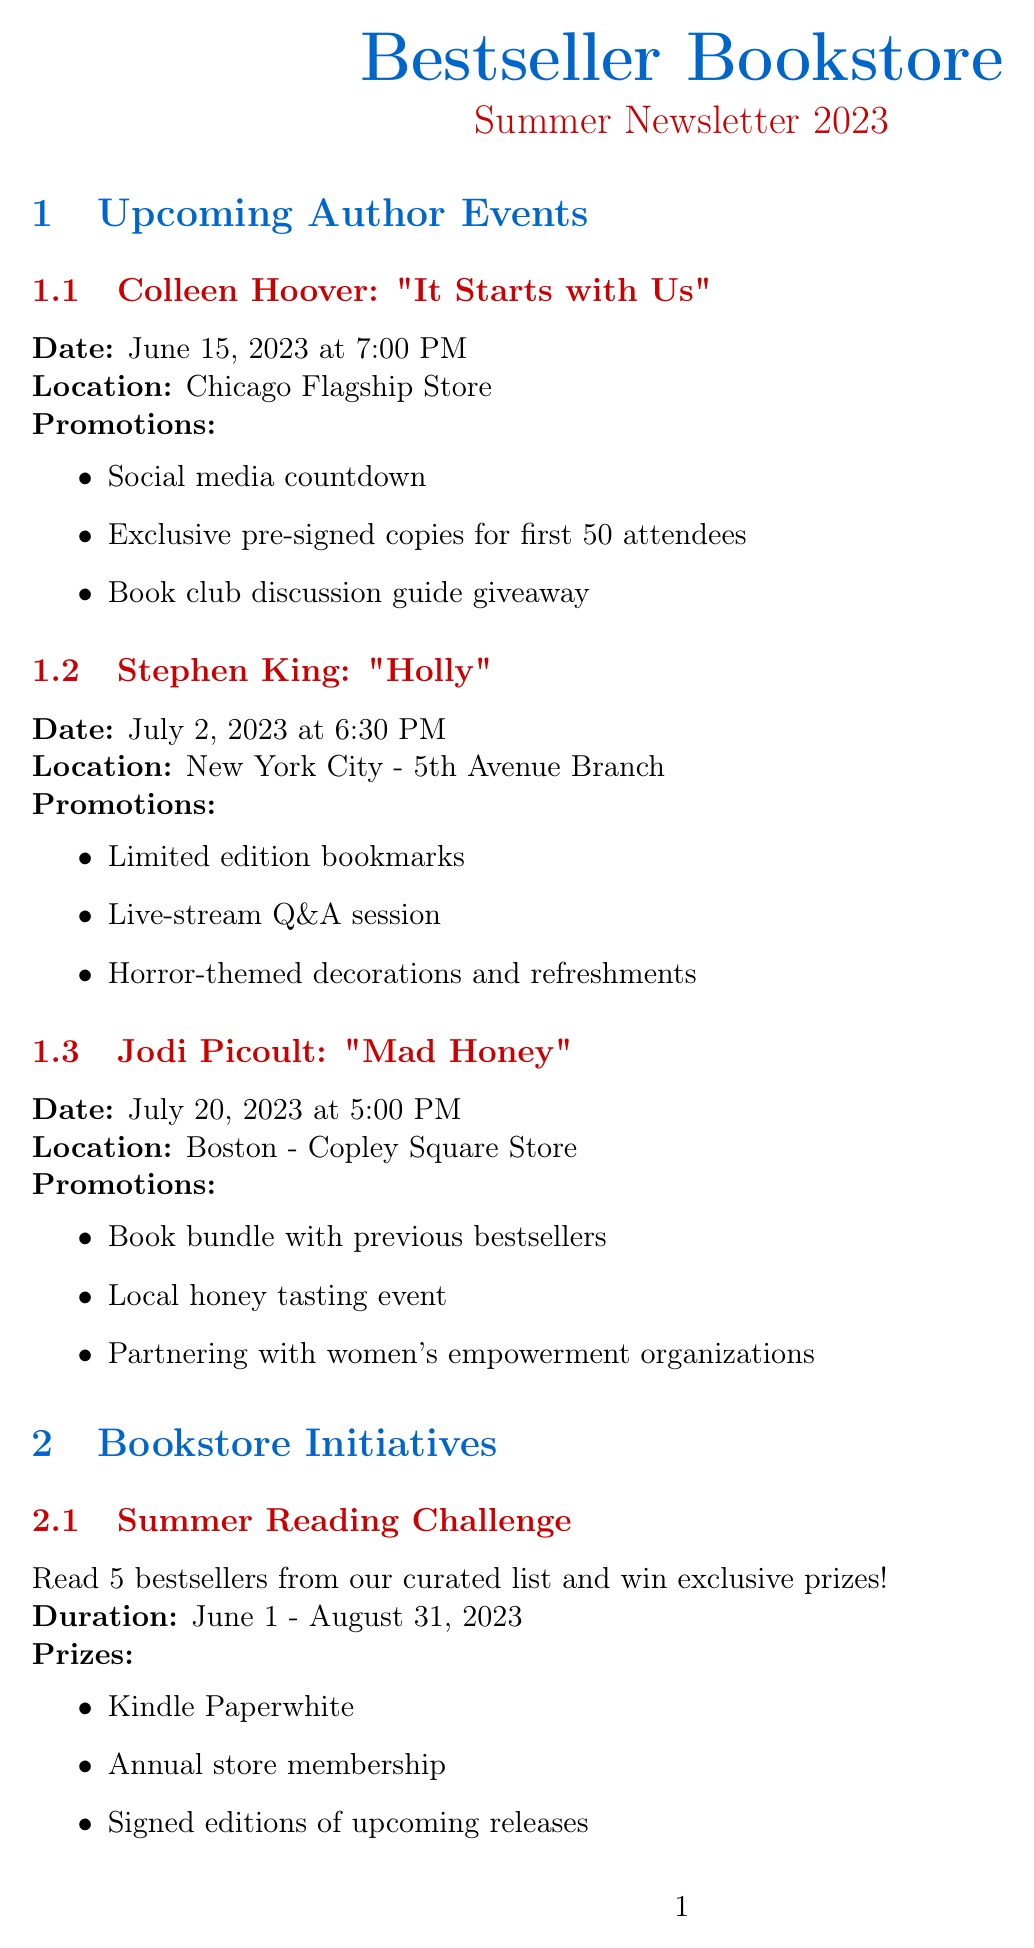What is the date of Colleen Hoover's event? The event is scheduled for June 15, 2023, according to the document.
Answer: June 15, 2023 What is the title of Stephen King's new book? The document mentions that his new book is titled "Holly."
Answer: Holly How many promotional strategies are listed for Jodi Picoult's event? There are three promotional strategies outlined for Jodi Picoult's event in the document.
Answer: 3 Where is the Summer Reading Challenge taking place? The document specifies that the Summer Reading Challenge is held at the bookstore.
Answer: At the bookstore What is the goal number of books for the community outreach program? The document states the goal for the community outreach program is set at 5,000 books.
Answer: 5,000 books Which month does the Bestseller Book Club meet? The document indicates that the Bestseller Book Club meets monthly, specifically on the first Thursday of every month.
Answer: Every month What special offer is provided for pre-ordering “The Paris Apartment”? The document mentions a chance to win a trip to Paris for pre-orders.
Answer: Chance to win a trip to Paris What time is Jodi Picoult's event scheduled for? The event is scheduled for 5:00 PM according to the document.
Answer: 5:00 PM 